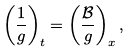Convert formula to latex. <formula><loc_0><loc_0><loc_500><loc_500>\left ( \frac { 1 } { g } \right ) _ { t } = \left ( \frac { \mathcal { B } } { g } \right ) _ { x } ,</formula> 